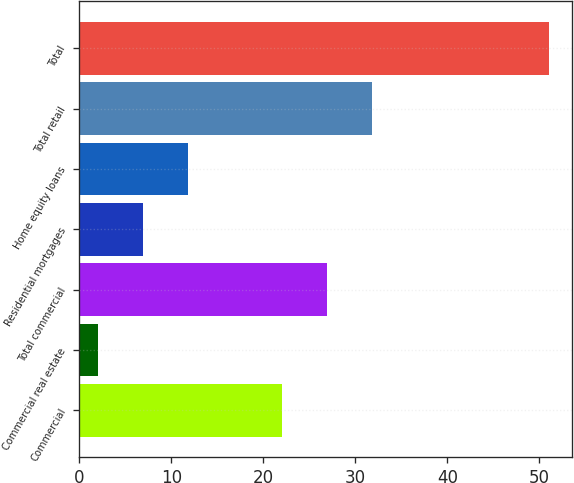Convert chart. <chart><loc_0><loc_0><loc_500><loc_500><bar_chart><fcel>Commercial<fcel>Commercial real estate<fcel>Total commercial<fcel>Residential mortgages<fcel>Home equity loans<fcel>Total retail<fcel>Total<nl><fcel>22<fcel>2<fcel>26.9<fcel>6.9<fcel>11.8<fcel>31.8<fcel>51<nl></chart> 